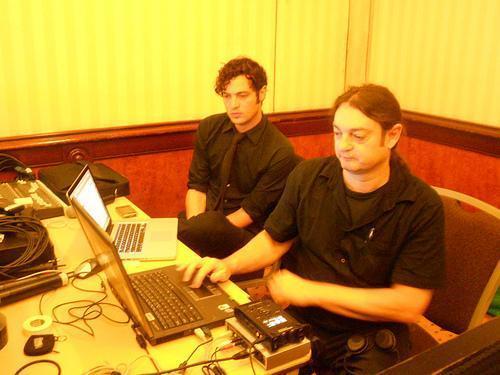How many people are in the photo?
Give a very brief answer. 2. How many computers are in the photo?
Give a very brief answer. 2. How many men are wearing ties?
Give a very brief answer. 1. 